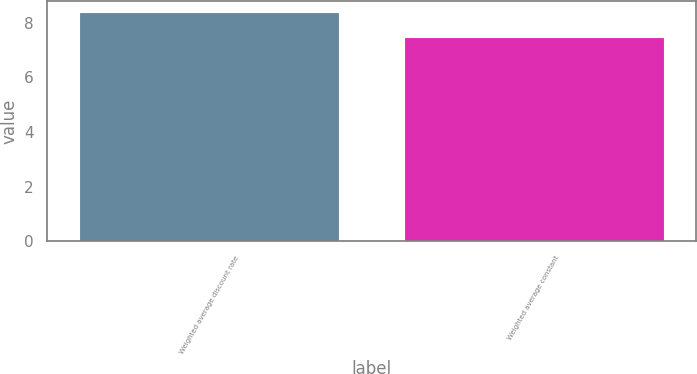<chart> <loc_0><loc_0><loc_500><loc_500><bar_chart><fcel>Weighted average discount rate<fcel>Weighted average constant<nl><fcel>8.4<fcel>7.5<nl></chart> 